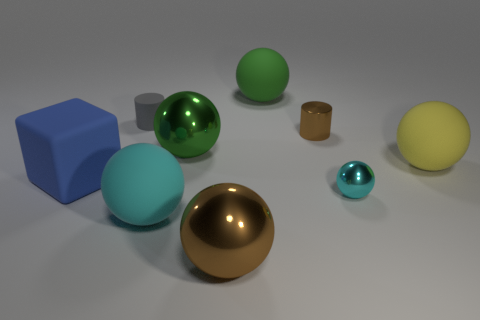Subtract all green metallic spheres. How many spheres are left? 5 Add 1 large blue matte things. How many objects exist? 10 Subtract all gray cylinders. How many cylinders are left? 1 Add 2 big green things. How many big green things exist? 4 Subtract 0 brown blocks. How many objects are left? 9 Subtract all cylinders. How many objects are left? 7 Subtract 1 spheres. How many spheres are left? 5 Subtract all yellow cubes. Subtract all gray cylinders. How many cubes are left? 1 Subtract all green cylinders. How many cyan spheres are left? 2 Subtract all big balls. Subtract all small things. How many objects are left? 1 